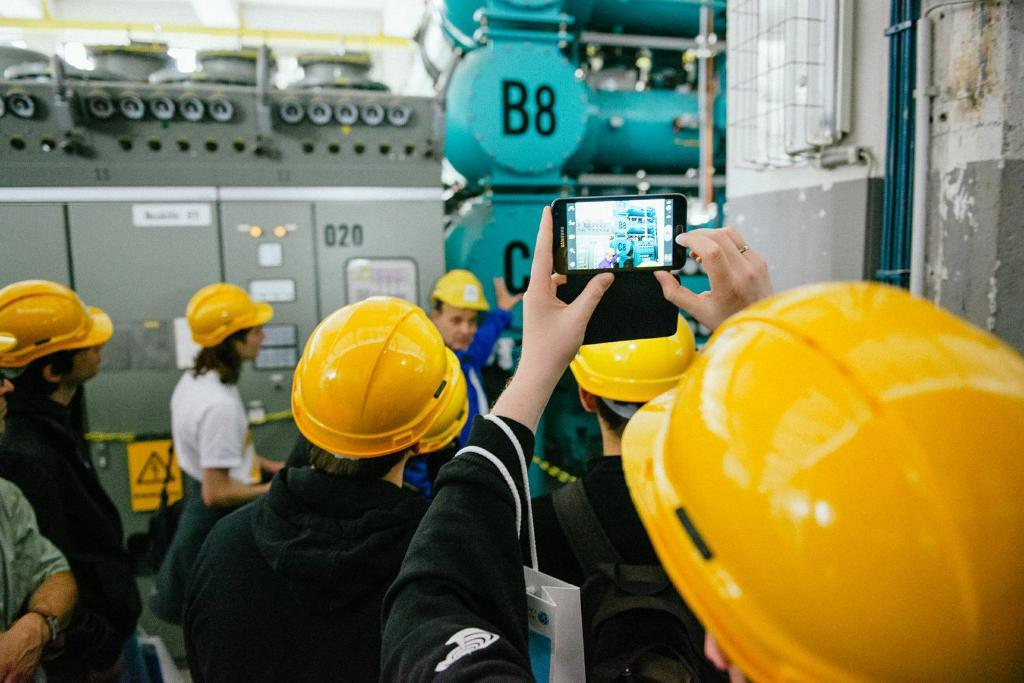What is the person on the right side of the image wearing? The person is wearing a yellow helmet. What is the person holding in the image? The person is holding a mobile. What are the people wearing yellow helmets doing in the image? They are being captured by the person holding the mobile. What type of equipment can be seen in the image? There are machines in the image. What is the tax rate for the machines in the image? There is no information about tax rates in the image, as it focuses on the people wearing yellow helmets and the person capturing them with a mobile. 